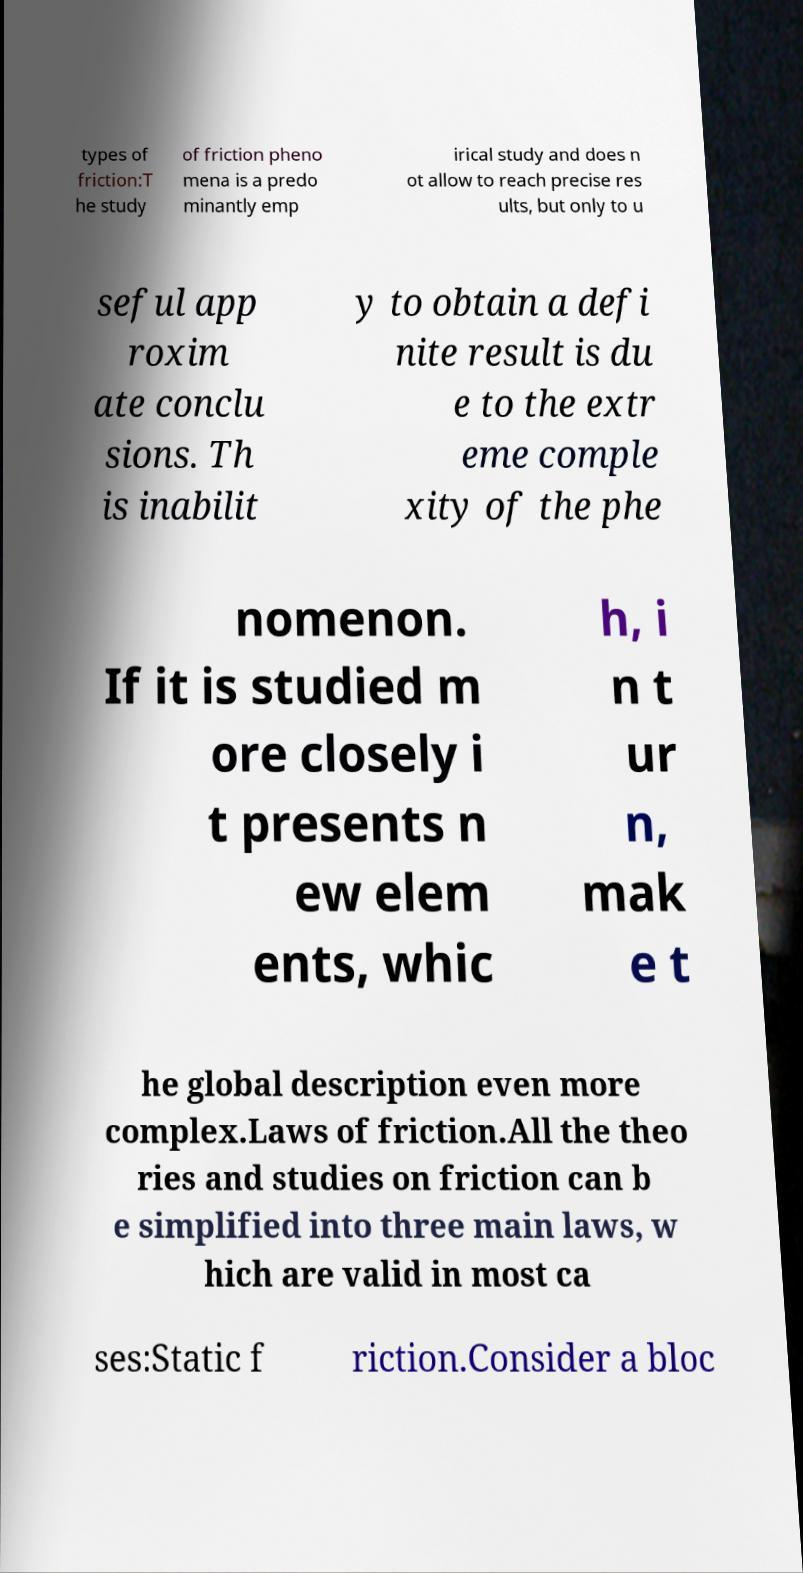I need the written content from this picture converted into text. Can you do that? types of friction:T he study of friction pheno mena is a predo minantly emp irical study and does n ot allow to reach precise res ults, but only to u seful app roxim ate conclu sions. Th is inabilit y to obtain a defi nite result is du e to the extr eme comple xity of the phe nomenon. If it is studied m ore closely i t presents n ew elem ents, whic h, i n t ur n, mak e t he global description even more complex.Laws of friction.All the theo ries and studies on friction can b e simplified into three main laws, w hich are valid in most ca ses:Static f riction.Consider a bloc 